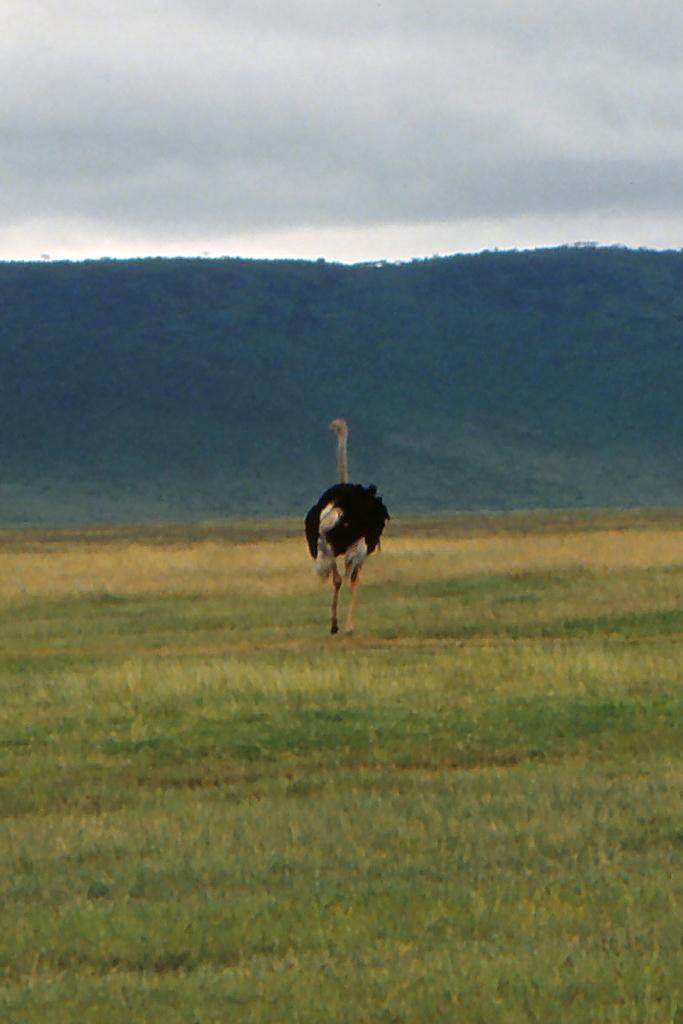In one or two sentences, can you explain what this image depicts? In this picture we can see an ostrich bird on the grass, in the background we can find a hill and clouds. 